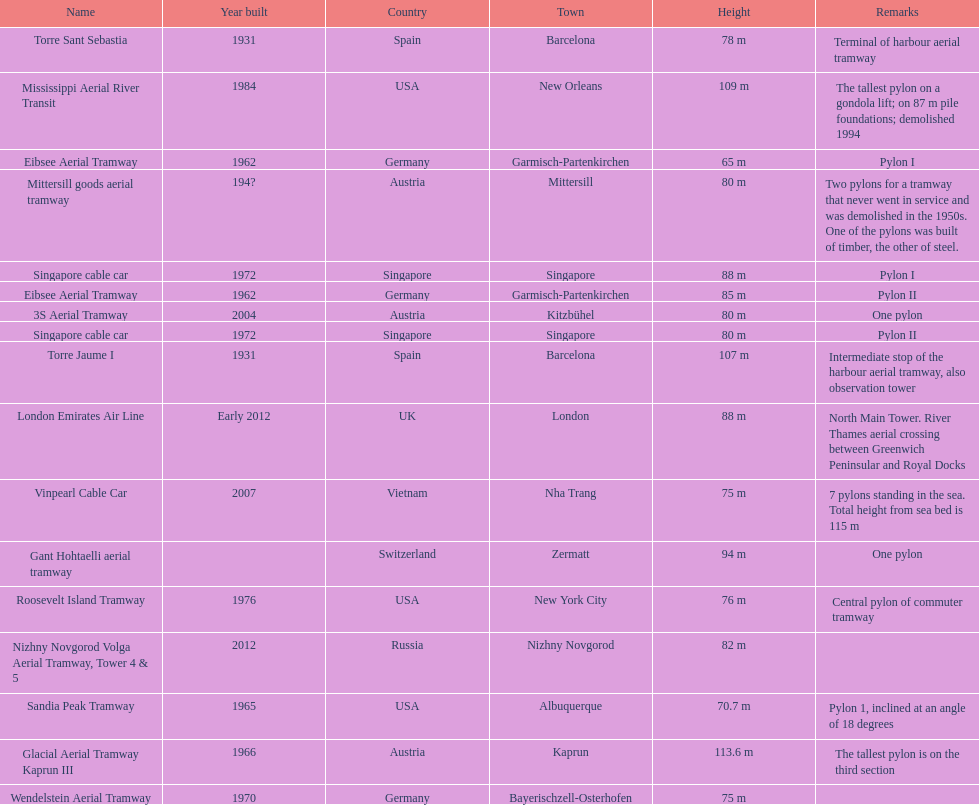The height of the london emirates air line pylon is equivalent to which other pylon? Singapore cable car. 